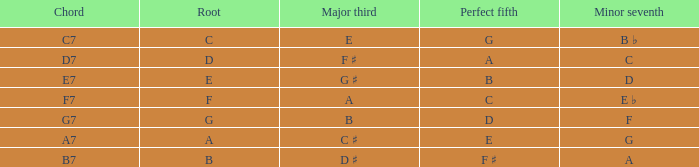What is the Major third with a Perfect fifth that is d? B. 